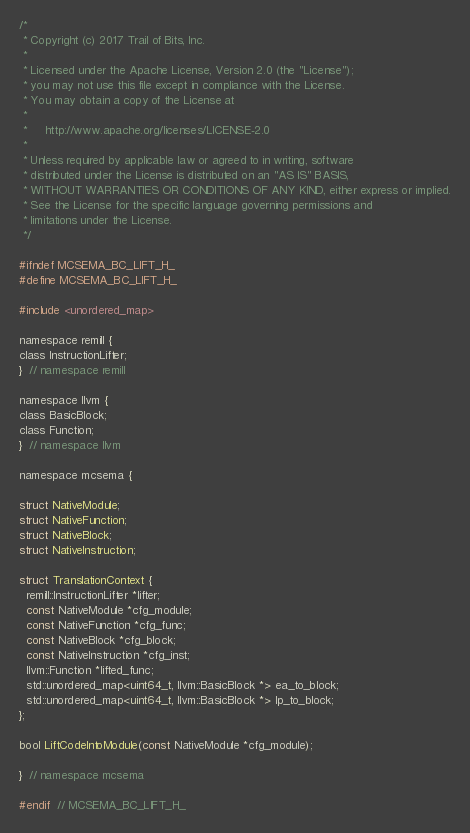<code> <loc_0><loc_0><loc_500><loc_500><_C_>/*
 * Copyright (c) 2017 Trail of Bits, Inc.
 *
 * Licensed under the Apache License, Version 2.0 (the "License");
 * you may not use this file except in compliance with the License.
 * You may obtain a copy of the License at
 *
 *     http://www.apache.org/licenses/LICENSE-2.0
 *
 * Unless required by applicable law or agreed to in writing, software
 * distributed under the License is distributed on an "AS IS" BASIS,
 * WITHOUT WARRANTIES OR CONDITIONS OF ANY KIND, either express or implied.
 * See the License for the specific language governing permissions and
 * limitations under the License.
 */

#ifndef MCSEMA_BC_LIFT_H_
#define MCSEMA_BC_LIFT_H_

#include <unordered_map>

namespace remill {
class InstructionLifter;
}  // namespace remill

namespace llvm {
class BasicBlock;
class Function;
}  // namespace llvm

namespace mcsema {

struct NativeModule;
struct NativeFunction;
struct NativeBlock;
struct NativeInstruction;

struct TranslationContext {
  remill::InstructionLifter *lifter;
  const NativeModule *cfg_module;
  const NativeFunction *cfg_func;
  const NativeBlock *cfg_block;
  const NativeInstruction *cfg_inst;
  llvm::Function *lifted_func;
  std::unordered_map<uint64_t, llvm::BasicBlock *> ea_to_block;
  std::unordered_map<uint64_t, llvm::BasicBlock *> lp_to_block;
};

bool LiftCodeIntoModule(const NativeModule *cfg_module);

}  // namespace mcsema

#endif  // MCSEMA_BC_LIFT_H_
</code> 